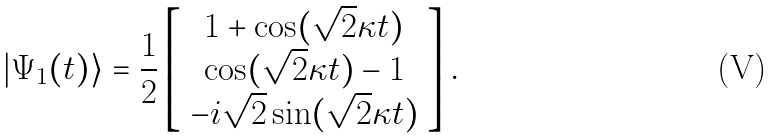<formula> <loc_0><loc_0><loc_500><loc_500>| \Psi _ { 1 } ( t ) \rangle = \frac { 1 } { 2 } \left [ \begin{array} { c } 1 + \cos ( \sqrt { 2 } \kappa t ) \\ \cos ( \sqrt { 2 } \kappa t ) - 1 \\ - i \sqrt { 2 } \sin ( \sqrt { 2 } \kappa t ) \end{array} \right ] .</formula> 